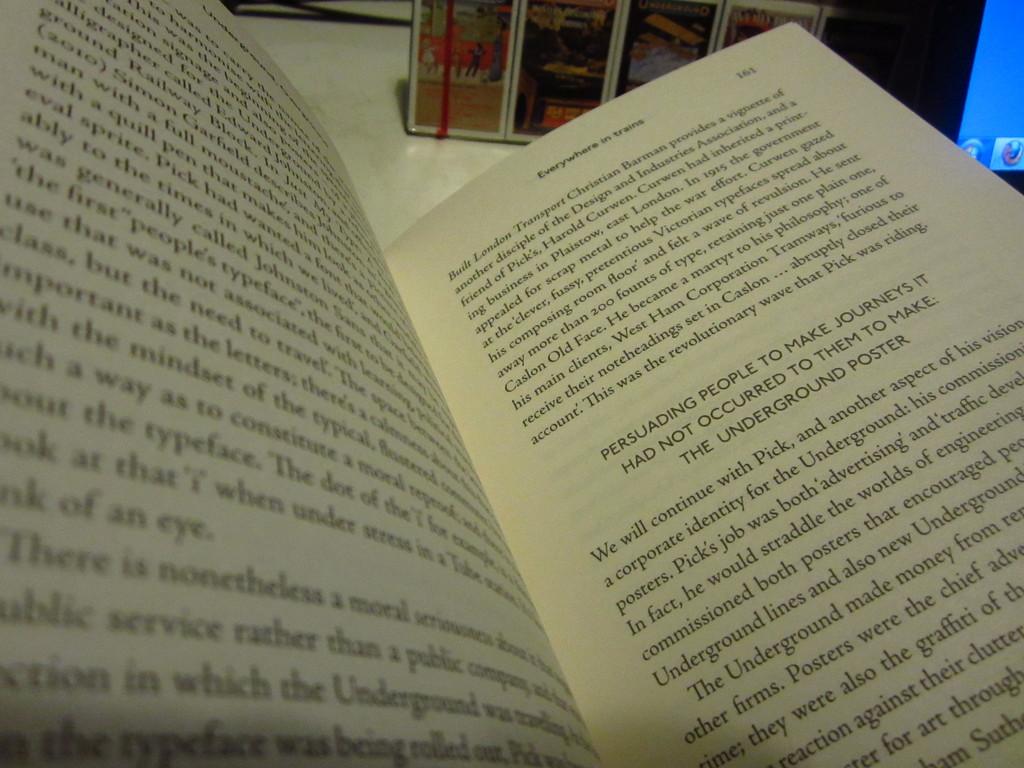Persuading people to make?
Provide a short and direct response. Journeys. 